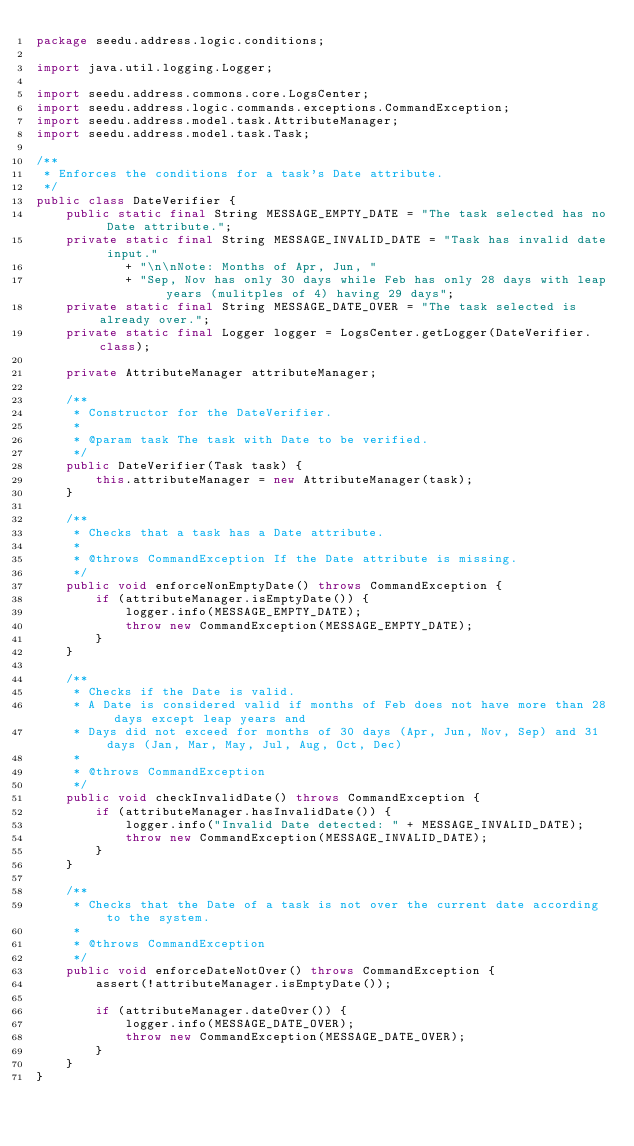Convert code to text. <code><loc_0><loc_0><loc_500><loc_500><_Java_>package seedu.address.logic.conditions;

import java.util.logging.Logger;

import seedu.address.commons.core.LogsCenter;
import seedu.address.logic.commands.exceptions.CommandException;
import seedu.address.model.task.AttributeManager;
import seedu.address.model.task.Task;

/**
 * Enforces the conditions for a task's Date attribute.
 */
public class DateVerifier {
    public static final String MESSAGE_EMPTY_DATE = "The task selected has no Date attribute.";
    private static final String MESSAGE_INVALID_DATE = "Task has invalid date input."
            + "\n\nNote: Months of Apr, Jun, "
            + "Sep, Nov has only 30 days while Feb has only 28 days with leap years (mulitples of 4) having 29 days";
    private static final String MESSAGE_DATE_OVER = "The task selected is already over.";
    private static final Logger logger = LogsCenter.getLogger(DateVerifier.class);

    private AttributeManager attributeManager;

    /**
     * Constructor for the DateVerifier.
     *
     * @param task The task with Date to be verified.
     */
    public DateVerifier(Task task) {
        this.attributeManager = new AttributeManager(task);
    }

    /**
     * Checks that a task has a Date attribute.
     *
     * @throws CommandException If the Date attribute is missing.
     */
    public void enforceNonEmptyDate() throws CommandException {
        if (attributeManager.isEmptyDate()) {
            logger.info(MESSAGE_EMPTY_DATE);
            throw new CommandException(MESSAGE_EMPTY_DATE);
        }
    }

    /**
     * Checks if the Date is valid.
     * A Date is considered valid if months of Feb does not have more than 28 days except leap years and
     * Days did not exceed for months of 30 days (Apr, Jun, Nov, Sep) and 31 days (Jan, Mar, May, Jul, Aug, Oct, Dec)
     *
     * @throws CommandException
     */
    public void checkInvalidDate() throws CommandException {
        if (attributeManager.hasInvalidDate()) {
            logger.info("Invalid Date detected: " + MESSAGE_INVALID_DATE);
            throw new CommandException(MESSAGE_INVALID_DATE);
        }
    }

    /**
     * Checks that the Date of a task is not over the current date according to the system.
     *
     * @throws CommandException
     */
    public void enforceDateNotOver() throws CommandException {
        assert(!attributeManager.isEmptyDate());

        if (attributeManager.dateOver()) {
            logger.info(MESSAGE_DATE_OVER);
            throw new CommandException(MESSAGE_DATE_OVER);
        }
    }
}
</code> 